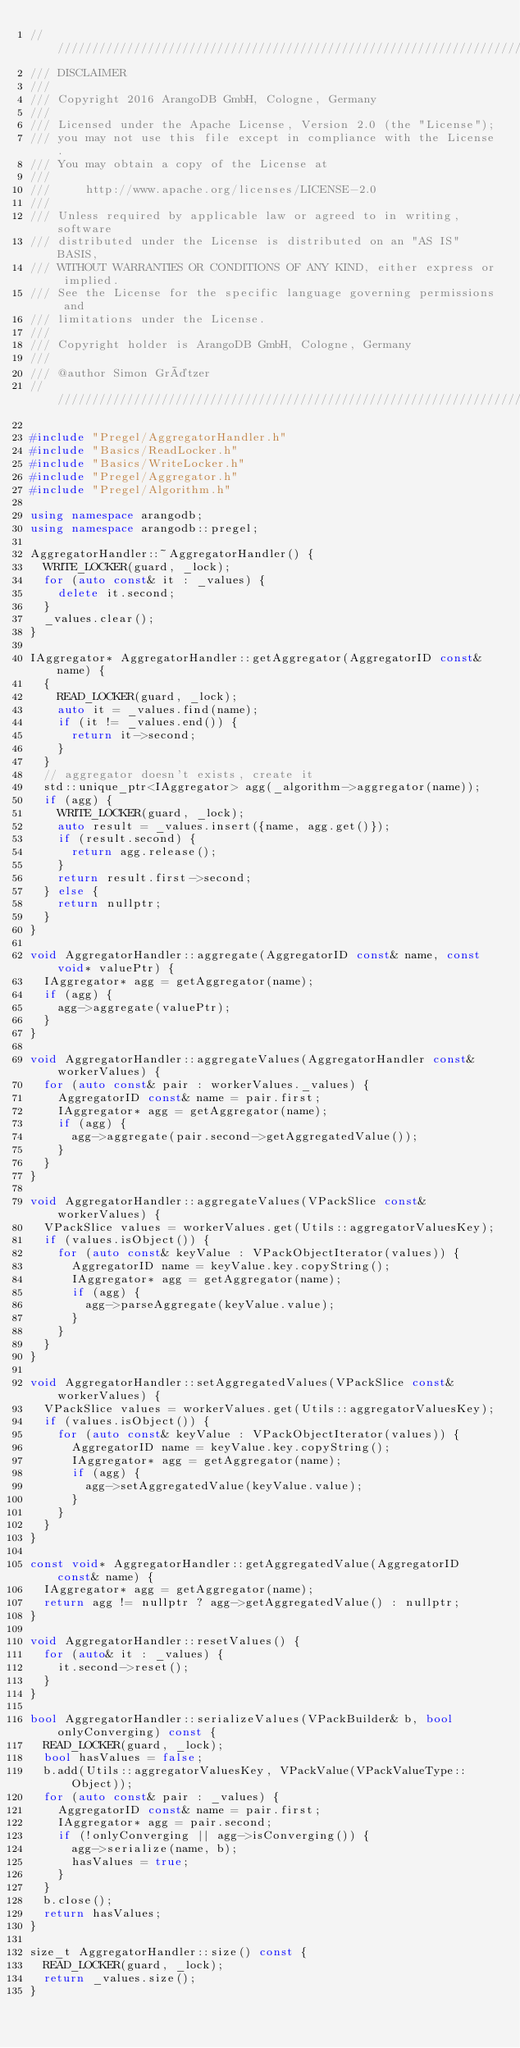Convert code to text. <code><loc_0><loc_0><loc_500><loc_500><_C++_>////////////////////////////////////////////////////////////////////////////////
/// DISCLAIMER
///
/// Copyright 2016 ArangoDB GmbH, Cologne, Germany
///
/// Licensed under the Apache License, Version 2.0 (the "License");
/// you may not use this file except in compliance with the License.
/// You may obtain a copy of the License at
///
///     http://www.apache.org/licenses/LICENSE-2.0
///
/// Unless required by applicable law or agreed to in writing, software
/// distributed under the License is distributed on an "AS IS" BASIS,
/// WITHOUT WARRANTIES OR CONDITIONS OF ANY KIND, either express or implied.
/// See the License for the specific language governing permissions and
/// limitations under the License.
///
/// Copyright holder is ArangoDB GmbH, Cologne, Germany
///
/// @author Simon Grätzer
////////////////////////////////////////////////////////////////////////////////

#include "Pregel/AggregatorHandler.h"
#include "Basics/ReadLocker.h"
#include "Basics/WriteLocker.h"
#include "Pregel/Aggregator.h"
#include "Pregel/Algorithm.h"

using namespace arangodb;
using namespace arangodb::pregel;

AggregatorHandler::~AggregatorHandler() {
  WRITE_LOCKER(guard, _lock);
  for (auto const& it : _values) {
    delete it.second;
  }
  _values.clear();
}

IAggregator* AggregatorHandler::getAggregator(AggregatorID const& name) {
  {
    READ_LOCKER(guard, _lock);
    auto it = _values.find(name);
    if (it != _values.end()) {
      return it->second;
    }
  }
  // aggregator doesn't exists, create it
  std::unique_ptr<IAggregator> agg(_algorithm->aggregator(name));
  if (agg) {
    WRITE_LOCKER(guard, _lock);
    auto result = _values.insert({name, agg.get()});
    if (result.second) {
      return agg.release();
    }
    return result.first->second;
  } else {
    return nullptr;
  }
}

void AggregatorHandler::aggregate(AggregatorID const& name, const void* valuePtr) {
  IAggregator* agg = getAggregator(name);
  if (agg) {
    agg->aggregate(valuePtr);
  }
}

void AggregatorHandler::aggregateValues(AggregatorHandler const& workerValues) {
  for (auto const& pair : workerValues._values) {
    AggregatorID const& name = pair.first;
    IAggregator* agg = getAggregator(name);
    if (agg) {
      agg->aggregate(pair.second->getAggregatedValue());
    }
  }
}

void AggregatorHandler::aggregateValues(VPackSlice const& workerValues) {
  VPackSlice values = workerValues.get(Utils::aggregatorValuesKey);
  if (values.isObject()) {
    for (auto const& keyValue : VPackObjectIterator(values)) {
      AggregatorID name = keyValue.key.copyString();
      IAggregator* agg = getAggregator(name);
      if (agg) {
        agg->parseAggregate(keyValue.value);
      }
    }
  }
}

void AggregatorHandler::setAggregatedValues(VPackSlice const& workerValues) {
  VPackSlice values = workerValues.get(Utils::aggregatorValuesKey);
  if (values.isObject()) {
    for (auto const& keyValue : VPackObjectIterator(values)) {
      AggregatorID name = keyValue.key.copyString();
      IAggregator* agg = getAggregator(name);
      if (agg) {
        agg->setAggregatedValue(keyValue.value);
      }
    }
  }
}

const void* AggregatorHandler::getAggregatedValue(AggregatorID const& name) {
  IAggregator* agg = getAggregator(name);
  return agg != nullptr ? agg->getAggregatedValue() : nullptr;
}

void AggregatorHandler::resetValues() {
  for (auto& it : _values) {
    it.second->reset();
  }
}

bool AggregatorHandler::serializeValues(VPackBuilder& b, bool onlyConverging) const {
  READ_LOCKER(guard, _lock);
  bool hasValues = false;
  b.add(Utils::aggregatorValuesKey, VPackValue(VPackValueType::Object));
  for (auto const& pair : _values) {
    AggregatorID const& name = pair.first;
    IAggregator* agg = pair.second;
    if (!onlyConverging || agg->isConverging()) {
      agg->serialize(name, b);
      hasValues = true;
    }
  }
  b.close();
  return hasValues;
}

size_t AggregatorHandler::size() const {
  READ_LOCKER(guard, _lock);
  return _values.size();
}
</code> 